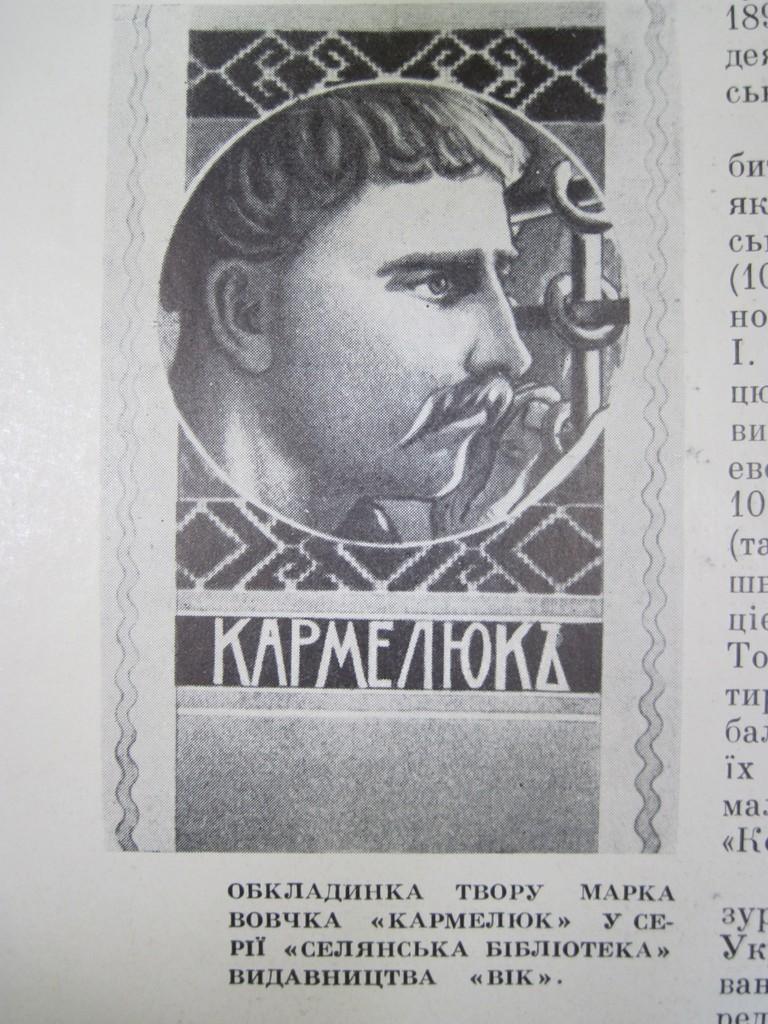How would you summarize this image in a sentence or two? In this picture, we see a newspaper containing the picture of a man. We see some text written on the paper. 